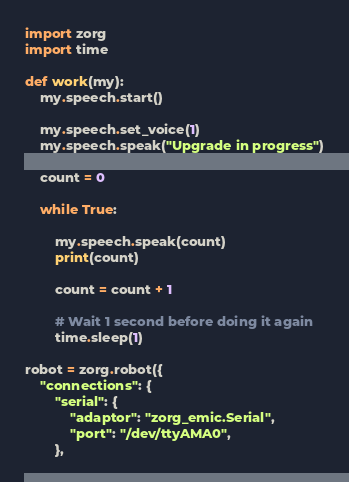Convert code to text. <code><loc_0><loc_0><loc_500><loc_500><_Python_>import zorg
import time

def work(my):
    my.speech.start()

    my.speech.set_voice(1)
    my.speech.speak("Upgrade in progress")

    count = 0

    while True:

        my.speech.speak(count)
        print(count)

        count = count + 1

        # Wait 1 second before doing it again
        time.sleep(1)

robot = zorg.robot({
    "connections": {
        "serial": {
            "adaptor": "zorg_emic.Serial",
            "port": "/dev/ttyAMA0",
        },</code> 